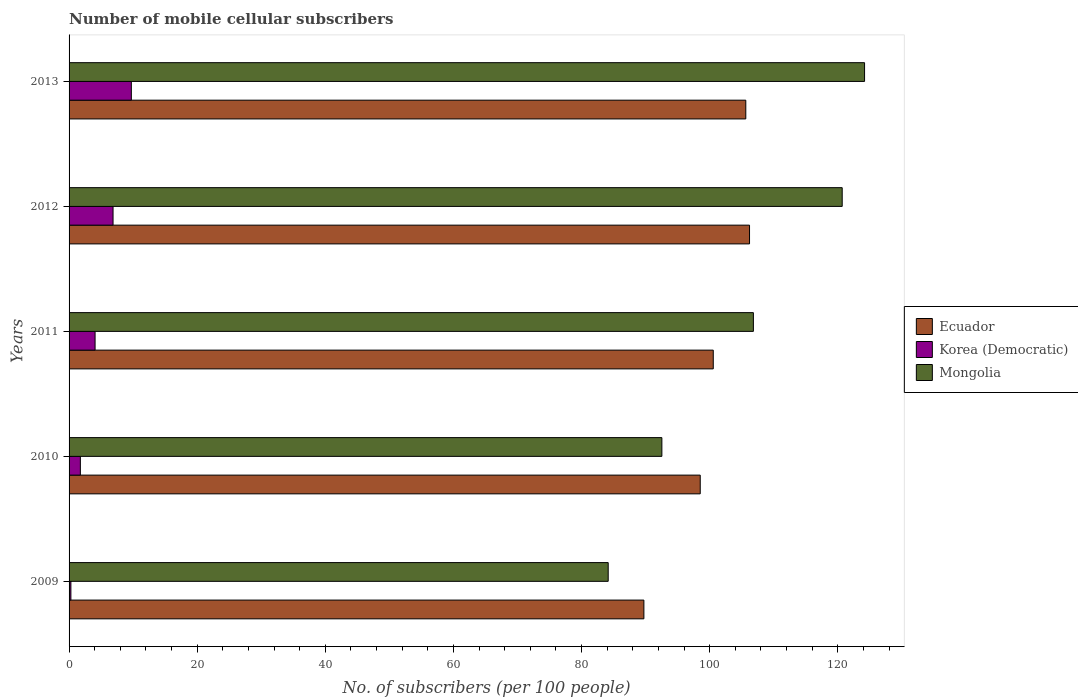How many different coloured bars are there?
Keep it short and to the point. 3. Are the number of bars per tick equal to the number of legend labels?
Provide a succinct answer. Yes. How many bars are there on the 5th tick from the top?
Make the answer very short. 3. How many bars are there on the 3rd tick from the bottom?
Offer a very short reply. 3. What is the label of the 5th group of bars from the top?
Your answer should be very brief. 2009. What is the number of mobile cellular subscribers in Korea (Democratic) in 2011?
Ensure brevity in your answer.  4.06. Across all years, what is the maximum number of mobile cellular subscribers in Ecuador?
Your answer should be compact. 106.23. Across all years, what is the minimum number of mobile cellular subscribers in Mongolia?
Your response must be concise. 84.16. In which year was the number of mobile cellular subscribers in Mongolia maximum?
Offer a terse response. 2013. What is the total number of mobile cellular subscribers in Korea (Democratic) in the graph?
Your answer should be compact. 22.69. What is the difference between the number of mobile cellular subscribers in Korea (Democratic) in 2009 and that in 2013?
Ensure brevity in your answer.  -9.44. What is the difference between the number of mobile cellular subscribers in Korea (Democratic) in 2010 and the number of mobile cellular subscribers in Ecuador in 2009?
Your response must be concise. -87.97. What is the average number of mobile cellular subscribers in Ecuador per year?
Give a very brief answer. 100.14. In the year 2009, what is the difference between the number of mobile cellular subscribers in Mongolia and number of mobile cellular subscribers in Korea (Democratic)?
Your response must be concise. 83.88. What is the ratio of the number of mobile cellular subscribers in Korea (Democratic) in 2009 to that in 2010?
Give a very brief answer. 0.16. What is the difference between the highest and the second highest number of mobile cellular subscribers in Korea (Democratic)?
Your answer should be very brief. 2.86. What is the difference between the highest and the lowest number of mobile cellular subscribers in Korea (Democratic)?
Give a very brief answer. 9.44. Is the sum of the number of mobile cellular subscribers in Korea (Democratic) in 2009 and 2012 greater than the maximum number of mobile cellular subscribers in Ecuador across all years?
Your response must be concise. No. What does the 3rd bar from the top in 2012 represents?
Offer a terse response. Ecuador. What does the 2nd bar from the bottom in 2012 represents?
Provide a short and direct response. Korea (Democratic). How many bars are there?
Offer a terse response. 15. What is the difference between two consecutive major ticks on the X-axis?
Your answer should be compact. 20. Are the values on the major ticks of X-axis written in scientific E-notation?
Provide a succinct answer. No. How many legend labels are there?
Ensure brevity in your answer.  3. How are the legend labels stacked?
Make the answer very short. Vertical. What is the title of the graph?
Give a very brief answer. Number of mobile cellular subscribers. What is the label or title of the X-axis?
Make the answer very short. No. of subscribers (per 100 people). What is the No. of subscribers (per 100 people) in Ecuador in 2009?
Ensure brevity in your answer.  89.74. What is the No. of subscribers (per 100 people) of Korea (Democratic) in 2009?
Ensure brevity in your answer.  0.28. What is the No. of subscribers (per 100 people) in Mongolia in 2009?
Offer a terse response. 84.16. What is the No. of subscribers (per 100 people) of Ecuador in 2010?
Your answer should be very brief. 98.53. What is the No. of subscribers (per 100 people) in Korea (Democratic) in 2010?
Give a very brief answer. 1.76. What is the No. of subscribers (per 100 people) in Mongolia in 2010?
Offer a very short reply. 92.54. What is the No. of subscribers (per 100 people) of Ecuador in 2011?
Your answer should be compact. 100.57. What is the No. of subscribers (per 100 people) in Korea (Democratic) in 2011?
Keep it short and to the point. 4.06. What is the No. of subscribers (per 100 people) in Mongolia in 2011?
Offer a terse response. 106.83. What is the No. of subscribers (per 100 people) of Ecuador in 2012?
Provide a succinct answer. 106.23. What is the No. of subscribers (per 100 people) in Korea (Democratic) in 2012?
Provide a short and direct response. 6.87. What is the No. of subscribers (per 100 people) of Mongolia in 2012?
Offer a very short reply. 120.69. What is the No. of subscribers (per 100 people) of Ecuador in 2013?
Give a very brief answer. 105.64. What is the No. of subscribers (per 100 people) of Korea (Democratic) in 2013?
Ensure brevity in your answer.  9.72. What is the No. of subscribers (per 100 people) in Mongolia in 2013?
Keep it short and to the point. 124.18. Across all years, what is the maximum No. of subscribers (per 100 people) of Ecuador?
Give a very brief answer. 106.23. Across all years, what is the maximum No. of subscribers (per 100 people) in Korea (Democratic)?
Provide a succinct answer. 9.72. Across all years, what is the maximum No. of subscribers (per 100 people) in Mongolia?
Offer a terse response. 124.18. Across all years, what is the minimum No. of subscribers (per 100 people) of Ecuador?
Your answer should be compact. 89.74. Across all years, what is the minimum No. of subscribers (per 100 people) in Korea (Democratic)?
Give a very brief answer. 0.28. Across all years, what is the minimum No. of subscribers (per 100 people) in Mongolia?
Your response must be concise. 84.16. What is the total No. of subscribers (per 100 people) of Ecuador in the graph?
Offer a very short reply. 500.7. What is the total No. of subscribers (per 100 people) in Korea (Democratic) in the graph?
Give a very brief answer. 22.69. What is the total No. of subscribers (per 100 people) of Mongolia in the graph?
Your response must be concise. 528.42. What is the difference between the No. of subscribers (per 100 people) in Ecuador in 2009 and that in 2010?
Your answer should be very brief. -8.8. What is the difference between the No. of subscribers (per 100 people) in Korea (Democratic) in 2009 and that in 2010?
Make the answer very short. -1.48. What is the difference between the No. of subscribers (per 100 people) of Mongolia in 2009 and that in 2010?
Ensure brevity in your answer.  -8.38. What is the difference between the No. of subscribers (per 100 people) of Ecuador in 2009 and that in 2011?
Keep it short and to the point. -10.83. What is the difference between the No. of subscribers (per 100 people) of Korea (Democratic) in 2009 and that in 2011?
Give a very brief answer. -3.78. What is the difference between the No. of subscribers (per 100 people) in Mongolia in 2009 and that in 2011?
Give a very brief answer. -22.67. What is the difference between the No. of subscribers (per 100 people) in Ecuador in 2009 and that in 2012?
Your response must be concise. -16.49. What is the difference between the No. of subscribers (per 100 people) of Korea (Democratic) in 2009 and that in 2012?
Your answer should be very brief. -6.58. What is the difference between the No. of subscribers (per 100 people) in Mongolia in 2009 and that in 2012?
Your answer should be very brief. -36.53. What is the difference between the No. of subscribers (per 100 people) in Ecuador in 2009 and that in 2013?
Offer a very short reply. -15.91. What is the difference between the No. of subscribers (per 100 people) of Korea (Democratic) in 2009 and that in 2013?
Keep it short and to the point. -9.44. What is the difference between the No. of subscribers (per 100 people) in Mongolia in 2009 and that in 2013?
Your answer should be compact. -40.02. What is the difference between the No. of subscribers (per 100 people) of Ecuador in 2010 and that in 2011?
Offer a very short reply. -2.03. What is the difference between the No. of subscribers (per 100 people) in Korea (Democratic) in 2010 and that in 2011?
Offer a terse response. -2.3. What is the difference between the No. of subscribers (per 100 people) in Mongolia in 2010 and that in 2011?
Your answer should be very brief. -14.29. What is the difference between the No. of subscribers (per 100 people) in Ecuador in 2010 and that in 2012?
Provide a succinct answer. -7.69. What is the difference between the No. of subscribers (per 100 people) of Korea (Democratic) in 2010 and that in 2012?
Keep it short and to the point. -5.1. What is the difference between the No. of subscribers (per 100 people) in Mongolia in 2010 and that in 2012?
Provide a succinct answer. -28.15. What is the difference between the No. of subscribers (per 100 people) in Ecuador in 2010 and that in 2013?
Give a very brief answer. -7.11. What is the difference between the No. of subscribers (per 100 people) in Korea (Democratic) in 2010 and that in 2013?
Offer a terse response. -7.96. What is the difference between the No. of subscribers (per 100 people) in Mongolia in 2010 and that in 2013?
Your response must be concise. -31.64. What is the difference between the No. of subscribers (per 100 people) in Ecuador in 2011 and that in 2012?
Offer a very short reply. -5.66. What is the difference between the No. of subscribers (per 100 people) in Korea (Democratic) in 2011 and that in 2012?
Make the answer very short. -2.81. What is the difference between the No. of subscribers (per 100 people) in Mongolia in 2011 and that in 2012?
Provide a succinct answer. -13.86. What is the difference between the No. of subscribers (per 100 people) of Ecuador in 2011 and that in 2013?
Keep it short and to the point. -5.08. What is the difference between the No. of subscribers (per 100 people) in Korea (Democratic) in 2011 and that in 2013?
Provide a short and direct response. -5.66. What is the difference between the No. of subscribers (per 100 people) of Mongolia in 2011 and that in 2013?
Provide a succinct answer. -17.35. What is the difference between the No. of subscribers (per 100 people) of Ecuador in 2012 and that in 2013?
Give a very brief answer. 0.58. What is the difference between the No. of subscribers (per 100 people) in Korea (Democratic) in 2012 and that in 2013?
Give a very brief answer. -2.86. What is the difference between the No. of subscribers (per 100 people) of Mongolia in 2012 and that in 2013?
Provide a succinct answer. -3.49. What is the difference between the No. of subscribers (per 100 people) of Ecuador in 2009 and the No. of subscribers (per 100 people) of Korea (Democratic) in 2010?
Offer a terse response. 87.97. What is the difference between the No. of subscribers (per 100 people) in Ecuador in 2009 and the No. of subscribers (per 100 people) in Mongolia in 2010?
Provide a succinct answer. -2.81. What is the difference between the No. of subscribers (per 100 people) in Korea (Democratic) in 2009 and the No. of subscribers (per 100 people) in Mongolia in 2010?
Offer a very short reply. -92.26. What is the difference between the No. of subscribers (per 100 people) of Ecuador in 2009 and the No. of subscribers (per 100 people) of Korea (Democratic) in 2011?
Keep it short and to the point. 85.68. What is the difference between the No. of subscribers (per 100 people) in Ecuador in 2009 and the No. of subscribers (per 100 people) in Mongolia in 2011?
Make the answer very short. -17.09. What is the difference between the No. of subscribers (per 100 people) of Korea (Democratic) in 2009 and the No. of subscribers (per 100 people) of Mongolia in 2011?
Give a very brief answer. -106.55. What is the difference between the No. of subscribers (per 100 people) in Ecuador in 2009 and the No. of subscribers (per 100 people) in Korea (Democratic) in 2012?
Provide a succinct answer. 82.87. What is the difference between the No. of subscribers (per 100 people) of Ecuador in 2009 and the No. of subscribers (per 100 people) of Mongolia in 2012?
Your answer should be compact. -30.96. What is the difference between the No. of subscribers (per 100 people) in Korea (Democratic) in 2009 and the No. of subscribers (per 100 people) in Mongolia in 2012?
Offer a very short reply. -120.41. What is the difference between the No. of subscribers (per 100 people) in Ecuador in 2009 and the No. of subscribers (per 100 people) in Korea (Democratic) in 2013?
Give a very brief answer. 80.01. What is the difference between the No. of subscribers (per 100 people) in Ecuador in 2009 and the No. of subscribers (per 100 people) in Mongolia in 2013?
Ensure brevity in your answer.  -34.45. What is the difference between the No. of subscribers (per 100 people) in Korea (Democratic) in 2009 and the No. of subscribers (per 100 people) in Mongolia in 2013?
Offer a very short reply. -123.9. What is the difference between the No. of subscribers (per 100 people) in Ecuador in 2010 and the No. of subscribers (per 100 people) in Korea (Democratic) in 2011?
Provide a succinct answer. 94.47. What is the difference between the No. of subscribers (per 100 people) in Ecuador in 2010 and the No. of subscribers (per 100 people) in Mongolia in 2011?
Keep it short and to the point. -8.3. What is the difference between the No. of subscribers (per 100 people) in Korea (Democratic) in 2010 and the No. of subscribers (per 100 people) in Mongolia in 2011?
Your answer should be very brief. -105.07. What is the difference between the No. of subscribers (per 100 people) in Ecuador in 2010 and the No. of subscribers (per 100 people) in Korea (Democratic) in 2012?
Provide a succinct answer. 91.67. What is the difference between the No. of subscribers (per 100 people) of Ecuador in 2010 and the No. of subscribers (per 100 people) of Mongolia in 2012?
Provide a short and direct response. -22.16. What is the difference between the No. of subscribers (per 100 people) of Korea (Democratic) in 2010 and the No. of subscribers (per 100 people) of Mongolia in 2012?
Make the answer very short. -118.93. What is the difference between the No. of subscribers (per 100 people) in Ecuador in 2010 and the No. of subscribers (per 100 people) in Korea (Democratic) in 2013?
Your answer should be compact. 88.81. What is the difference between the No. of subscribers (per 100 people) of Ecuador in 2010 and the No. of subscribers (per 100 people) of Mongolia in 2013?
Your answer should be compact. -25.65. What is the difference between the No. of subscribers (per 100 people) of Korea (Democratic) in 2010 and the No. of subscribers (per 100 people) of Mongolia in 2013?
Your response must be concise. -122.42. What is the difference between the No. of subscribers (per 100 people) in Ecuador in 2011 and the No. of subscribers (per 100 people) in Korea (Democratic) in 2012?
Provide a succinct answer. 93.7. What is the difference between the No. of subscribers (per 100 people) of Ecuador in 2011 and the No. of subscribers (per 100 people) of Mongolia in 2012?
Make the answer very short. -20.13. What is the difference between the No. of subscribers (per 100 people) of Korea (Democratic) in 2011 and the No. of subscribers (per 100 people) of Mongolia in 2012?
Offer a very short reply. -116.63. What is the difference between the No. of subscribers (per 100 people) in Ecuador in 2011 and the No. of subscribers (per 100 people) in Korea (Democratic) in 2013?
Your answer should be very brief. 90.84. What is the difference between the No. of subscribers (per 100 people) in Ecuador in 2011 and the No. of subscribers (per 100 people) in Mongolia in 2013?
Make the answer very short. -23.62. What is the difference between the No. of subscribers (per 100 people) of Korea (Democratic) in 2011 and the No. of subscribers (per 100 people) of Mongolia in 2013?
Offer a very short reply. -120.12. What is the difference between the No. of subscribers (per 100 people) in Ecuador in 2012 and the No. of subscribers (per 100 people) in Korea (Democratic) in 2013?
Your answer should be very brief. 96.5. What is the difference between the No. of subscribers (per 100 people) of Ecuador in 2012 and the No. of subscribers (per 100 people) of Mongolia in 2013?
Provide a succinct answer. -17.96. What is the difference between the No. of subscribers (per 100 people) in Korea (Democratic) in 2012 and the No. of subscribers (per 100 people) in Mongolia in 2013?
Make the answer very short. -117.32. What is the average No. of subscribers (per 100 people) in Ecuador per year?
Make the answer very short. 100.14. What is the average No. of subscribers (per 100 people) of Korea (Democratic) per year?
Provide a succinct answer. 4.54. What is the average No. of subscribers (per 100 people) in Mongolia per year?
Your answer should be very brief. 105.68. In the year 2009, what is the difference between the No. of subscribers (per 100 people) in Ecuador and No. of subscribers (per 100 people) in Korea (Democratic)?
Your answer should be compact. 89.45. In the year 2009, what is the difference between the No. of subscribers (per 100 people) of Ecuador and No. of subscribers (per 100 people) of Mongolia?
Your response must be concise. 5.57. In the year 2009, what is the difference between the No. of subscribers (per 100 people) in Korea (Democratic) and No. of subscribers (per 100 people) in Mongolia?
Provide a succinct answer. -83.88. In the year 2010, what is the difference between the No. of subscribers (per 100 people) of Ecuador and No. of subscribers (per 100 people) of Korea (Democratic)?
Your response must be concise. 96.77. In the year 2010, what is the difference between the No. of subscribers (per 100 people) in Ecuador and No. of subscribers (per 100 people) in Mongolia?
Provide a succinct answer. 5.99. In the year 2010, what is the difference between the No. of subscribers (per 100 people) in Korea (Democratic) and No. of subscribers (per 100 people) in Mongolia?
Make the answer very short. -90.78. In the year 2011, what is the difference between the No. of subscribers (per 100 people) in Ecuador and No. of subscribers (per 100 people) in Korea (Democratic)?
Make the answer very short. 96.51. In the year 2011, what is the difference between the No. of subscribers (per 100 people) in Ecuador and No. of subscribers (per 100 people) in Mongolia?
Make the answer very short. -6.26. In the year 2011, what is the difference between the No. of subscribers (per 100 people) of Korea (Democratic) and No. of subscribers (per 100 people) of Mongolia?
Keep it short and to the point. -102.77. In the year 2012, what is the difference between the No. of subscribers (per 100 people) of Ecuador and No. of subscribers (per 100 people) of Korea (Democratic)?
Make the answer very short. 99.36. In the year 2012, what is the difference between the No. of subscribers (per 100 people) in Ecuador and No. of subscribers (per 100 people) in Mongolia?
Provide a short and direct response. -14.47. In the year 2012, what is the difference between the No. of subscribers (per 100 people) of Korea (Democratic) and No. of subscribers (per 100 people) of Mongolia?
Give a very brief answer. -113.83. In the year 2013, what is the difference between the No. of subscribers (per 100 people) of Ecuador and No. of subscribers (per 100 people) of Korea (Democratic)?
Your answer should be compact. 95.92. In the year 2013, what is the difference between the No. of subscribers (per 100 people) of Ecuador and No. of subscribers (per 100 people) of Mongolia?
Give a very brief answer. -18.54. In the year 2013, what is the difference between the No. of subscribers (per 100 people) in Korea (Democratic) and No. of subscribers (per 100 people) in Mongolia?
Keep it short and to the point. -114.46. What is the ratio of the No. of subscribers (per 100 people) of Ecuador in 2009 to that in 2010?
Offer a very short reply. 0.91. What is the ratio of the No. of subscribers (per 100 people) in Korea (Democratic) in 2009 to that in 2010?
Provide a short and direct response. 0.16. What is the ratio of the No. of subscribers (per 100 people) in Mongolia in 2009 to that in 2010?
Provide a short and direct response. 0.91. What is the ratio of the No. of subscribers (per 100 people) in Ecuador in 2009 to that in 2011?
Your answer should be very brief. 0.89. What is the ratio of the No. of subscribers (per 100 people) of Korea (Democratic) in 2009 to that in 2011?
Give a very brief answer. 0.07. What is the ratio of the No. of subscribers (per 100 people) in Mongolia in 2009 to that in 2011?
Your answer should be compact. 0.79. What is the ratio of the No. of subscribers (per 100 people) in Ecuador in 2009 to that in 2012?
Offer a terse response. 0.84. What is the ratio of the No. of subscribers (per 100 people) in Korea (Democratic) in 2009 to that in 2012?
Make the answer very short. 0.04. What is the ratio of the No. of subscribers (per 100 people) in Mongolia in 2009 to that in 2012?
Offer a terse response. 0.7. What is the ratio of the No. of subscribers (per 100 people) of Ecuador in 2009 to that in 2013?
Offer a very short reply. 0.85. What is the ratio of the No. of subscribers (per 100 people) of Korea (Democratic) in 2009 to that in 2013?
Offer a very short reply. 0.03. What is the ratio of the No. of subscribers (per 100 people) in Mongolia in 2009 to that in 2013?
Your answer should be very brief. 0.68. What is the ratio of the No. of subscribers (per 100 people) in Ecuador in 2010 to that in 2011?
Keep it short and to the point. 0.98. What is the ratio of the No. of subscribers (per 100 people) in Korea (Democratic) in 2010 to that in 2011?
Your answer should be compact. 0.43. What is the ratio of the No. of subscribers (per 100 people) of Mongolia in 2010 to that in 2011?
Give a very brief answer. 0.87. What is the ratio of the No. of subscribers (per 100 people) of Ecuador in 2010 to that in 2012?
Your answer should be compact. 0.93. What is the ratio of the No. of subscribers (per 100 people) of Korea (Democratic) in 2010 to that in 2012?
Provide a short and direct response. 0.26. What is the ratio of the No. of subscribers (per 100 people) of Mongolia in 2010 to that in 2012?
Your response must be concise. 0.77. What is the ratio of the No. of subscribers (per 100 people) in Ecuador in 2010 to that in 2013?
Your answer should be very brief. 0.93. What is the ratio of the No. of subscribers (per 100 people) in Korea (Democratic) in 2010 to that in 2013?
Your answer should be compact. 0.18. What is the ratio of the No. of subscribers (per 100 people) of Mongolia in 2010 to that in 2013?
Your response must be concise. 0.75. What is the ratio of the No. of subscribers (per 100 people) of Ecuador in 2011 to that in 2012?
Ensure brevity in your answer.  0.95. What is the ratio of the No. of subscribers (per 100 people) of Korea (Democratic) in 2011 to that in 2012?
Your response must be concise. 0.59. What is the ratio of the No. of subscribers (per 100 people) in Mongolia in 2011 to that in 2012?
Ensure brevity in your answer.  0.89. What is the ratio of the No. of subscribers (per 100 people) of Ecuador in 2011 to that in 2013?
Provide a succinct answer. 0.95. What is the ratio of the No. of subscribers (per 100 people) of Korea (Democratic) in 2011 to that in 2013?
Ensure brevity in your answer.  0.42. What is the ratio of the No. of subscribers (per 100 people) in Mongolia in 2011 to that in 2013?
Give a very brief answer. 0.86. What is the ratio of the No. of subscribers (per 100 people) of Korea (Democratic) in 2012 to that in 2013?
Your answer should be very brief. 0.71. What is the ratio of the No. of subscribers (per 100 people) of Mongolia in 2012 to that in 2013?
Offer a terse response. 0.97. What is the difference between the highest and the second highest No. of subscribers (per 100 people) in Ecuador?
Keep it short and to the point. 0.58. What is the difference between the highest and the second highest No. of subscribers (per 100 people) of Korea (Democratic)?
Keep it short and to the point. 2.86. What is the difference between the highest and the second highest No. of subscribers (per 100 people) in Mongolia?
Offer a terse response. 3.49. What is the difference between the highest and the lowest No. of subscribers (per 100 people) of Ecuador?
Offer a very short reply. 16.49. What is the difference between the highest and the lowest No. of subscribers (per 100 people) of Korea (Democratic)?
Offer a very short reply. 9.44. What is the difference between the highest and the lowest No. of subscribers (per 100 people) in Mongolia?
Provide a short and direct response. 40.02. 